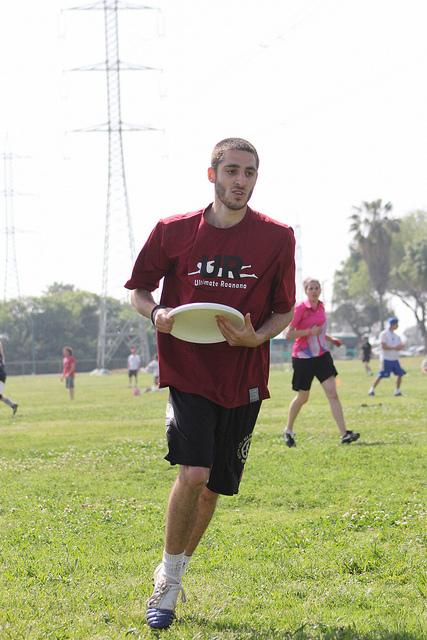What game is being played?
Quick response, please. Frisbee. What color is the man's frisbee?
Keep it brief. White. Where is the Frisbee?
Short answer required. Hands. Does the man have facial hair?
Short answer required. Yes. What color shirt is the man wearing?
Write a very short answer. Red. What is the woman in the background, shirt color?
Give a very brief answer. Pink. 